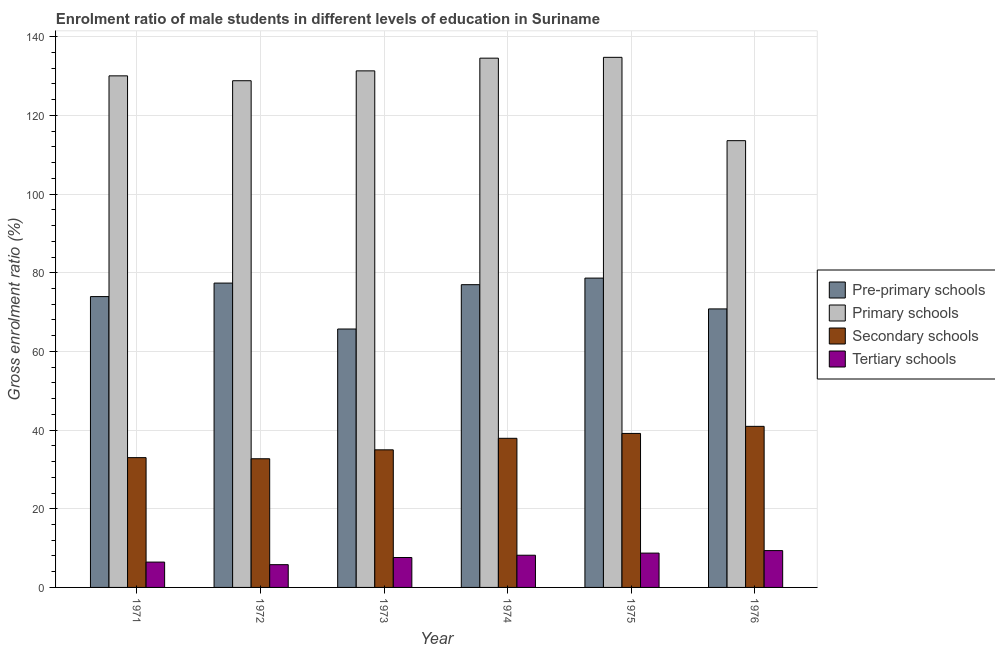How many different coloured bars are there?
Make the answer very short. 4. Are the number of bars per tick equal to the number of legend labels?
Make the answer very short. Yes. Are the number of bars on each tick of the X-axis equal?
Keep it short and to the point. Yes. What is the label of the 4th group of bars from the left?
Keep it short and to the point. 1974. What is the gross enrolment ratio(female) in secondary schools in 1974?
Make the answer very short. 37.91. Across all years, what is the maximum gross enrolment ratio(female) in secondary schools?
Your response must be concise. 40.95. Across all years, what is the minimum gross enrolment ratio(female) in primary schools?
Ensure brevity in your answer.  113.58. In which year was the gross enrolment ratio(female) in tertiary schools maximum?
Make the answer very short. 1976. What is the total gross enrolment ratio(female) in tertiary schools in the graph?
Your response must be concise. 46.11. What is the difference between the gross enrolment ratio(female) in primary schools in 1975 and that in 1976?
Your answer should be very brief. 21.19. What is the difference between the gross enrolment ratio(female) in tertiary schools in 1976 and the gross enrolment ratio(female) in secondary schools in 1975?
Ensure brevity in your answer.  0.64. What is the average gross enrolment ratio(female) in primary schools per year?
Provide a succinct answer. 128.85. In how many years, is the gross enrolment ratio(female) in secondary schools greater than 40 %?
Your answer should be very brief. 1. What is the ratio of the gross enrolment ratio(female) in secondary schools in 1971 to that in 1976?
Offer a very short reply. 0.81. Is the difference between the gross enrolment ratio(female) in pre-primary schools in 1971 and 1974 greater than the difference between the gross enrolment ratio(female) in secondary schools in 1971 and 1974?
Make the answer very short. No. What is the difference between the highest and the second highest gross enrolment ratio(female) in primary schools?
Your answer should be very brief. 0.21. What is the difference between the highest and the lowest gross enrolment ratio(female) in pre-primary schools?
Provide a short and direct response. 12.94. In how many years, is the gross enrolment ratio(female) in pre-primary schools greater than the average gross enrolment ratio(female) in pre-primary schools taken over all years?
Offer a terse response. 4. What does the 1st bar from the left in 1973 represents?
Give a very brief answer. Pre-primary schools. What does the 3rd bar from the right in 1972 represents?
Ensure brevity in your answer.  Primary schools. Is it the case that in every year, the sum of the gross enrolment ratio(female) in pre-primary schools and gross enrolment ratio(female) in primary schools is greater than the gross enrolment ratio(female) in secondary schools?
Your response must be concise. Yes. How many bars are there?
Provide a short and direct response. 24. Are the values on the major ticks of Y-axis written in scientific E-notation?
Keep it short and to the point. No. Does the graph contain any zero values?
Ensure brevity in your answer.  No. How are the legend labels stacked?
Ensure brevity in your answer.  Vertical. What is the title of the graph?
Keep it short and to the point. Enrolment ratio of male students in different levels of education in Suriname. What is the label or title of the Y-axis?
Your answer should be very brief. Gross enrolment ratio (%). What is the Gross enrolment ratio (%) of Pre-primary schools in 1971?
Keep it short and to the point. 73.94. What is the Gross enrolment ratio (%) of Primary schools in 1971?
Your answer should be compact. 130.06. What is the Gross enrolment ratio (%) of Secondary schools in 1971?
Give a very brief answer. 33. What is the Gross enrolment ratio (%) in Tertiary schools in 1971?
Ensure brevity in your answer.  6.44. What is the Gross enrolment ratio (%) of Pre-primary schools in 1972?
Keep it short and to the point. 77.37. What is the Gross enrolment ratio (%) in Primary schools in 1972?
Provide a short and direct response. 128.82. What is the Gross enrolment ratio (%) of Secondary schools in 1972?
Give a very brief answer. 32.71. What is the Gross enrolment ratio (%) of Tertiary schools in 1972?
Make the answer very short. 5.79. What is the Gross enrolment ratio (%) of Pre-primary schools in 1973?
Provide a succinct answer. 65.7. What is the Gross enrolment ratio (%) in Primary schools in 1973?
Provide a succinct answer. 131.33. What is the Gross enrolment ratio (%) in Secondary schools in 1973?
Make the answer very short. 34.98. What is the Gross enrolment ratio (%) of Tertiary schools in 1973?
Keep it short and to the point. 7.6. What is the Gross enrolment ratio (%) in Pre-primary schools in 1974?
Your answer should be compact. 76.97. What is the Gross enrolment ratio (%) of Primary schools in 1974?
Your answer should be compact. 134.56. What is the Gross enrolment ratio (%) in Secondary schools in 1974?
Provide a short and direct response. 37.91. What is the Gross enrolment ratio (%) of Tertiary schools in 1974?
Provide a short and direct response. 8.19. What is the Gross enrolment ratio (%) of Pre-primary schools in 1975?
Your answer should be very brief. 78.64. What is the Gross enrolment ratio (%) of Primary schools in 1975?
Your answer should be compact. 134.77. What is the Gross enrolment ratio (%) of Secondary schools in 1975?
Your answer should be very brief. 39.15. What is the Gross enrolment ratio (%) of Tertiary schools in 1975?
Your answer should be very brief. 8.72. What is the Gross enrolment ratio (%) of Pre-primary schools in 1976?
Ensure brevity in your answer.  70.81. What is the Gross enrolment ratio (%) of Primary schools in 1976?
Your response must be concise. 113.58. What is the Gross enrolment ratio (%) in Secondary schools in 1976?
Provide a succinct answer. 40.95. What is the Gross enrolment ratio (%) of Tertiary schools in 1976?
Your answer should be very brief. 9.37. Across all years, what is the maximum Gross enrolment ratio (%) in Pre-primary schools?
Ensure brevity in your answer.  78.64. Across all years, what is the maximum Gross enrolment ratio (%) of Primary schools?
Offer a very short reply. 134.77. Across all years, what is the maximum Gross enrolment ratio (%) in Secondary schools?
Ensure brevity in your answer.  40.95. Across all years, what is the maximum Gross enrolment ratio (%) in Tertiary schools?
Give a very brief answer. 9.37. Across all years, what is the minimum Gross enrolment ratio (%) of Pre-primary schools?
Offer a terse response. 65.7. Across all years, what is the minimum Gross enrolment ratio (%) in Primary schools?
Give a very brief answer. 113.58. Across all years, what is the minimum Gross enrolment ratio (%) of Secondary schools?
Your response must be concise. 32.71. Across all years, what is the minimum Gross enrolment ratio (%) in Tertiary schools?
Provide a short and direct response. 5.79. What is the total Gross enrolment ratio (%) in Pre-primary schools in the graph?
Your response must be concise. 443.44. What is the total Gross enrolment ratio (%) of Primary schools in the graph?
Your response must be concise. 773.13. What is the total Gross enrolment ratio (%) in Secondary schools in the graph?
Offer a very short reply. 218.71. What is the total Gross enrolment ratio (%) in Tertiary schools in the graph?
Offer a very short reply. 46.11. What is the difference between the Gross enrolment ratio (%) in Pre-primary schools in 1971 and that in 1972?
Provide a succinct answer. -3.43. What is the difference between the Gross enrolment ratio (%) of Primary schools in 1971 and that in 1972?
Give a very brief answer. 1.24. What is the difference between the Gross enrolment ratio (%) of Secondary schools in 1971 and that in 1972?
Offer a very short reply. 0.29. What is the difference between the Gross enrolment ratio (%) of Tertiary schools in 1971 and that in 1972?
Keep it short and to the point. 0.66. What is the difference between the Gross enrolment ratio (%) of Pre-primary schools in 1971 and that in 1973?
Your response must be concise. 8.24. What is the difference between the Gross enrolment ratio (%) of Primary schools in 1971 and that in 1973?
Provide a short and direct response. -1.26. What is the difference between the Gross enrolment ratio (%) of Secondary schools in 1971 and that in 1973?
Offer a terse response. -1.98. What is the difference between the Gross enrolment ratio (%) of Tertiary schools in 1971 and that in 1973?
Your answer should be very brief. -1.16. What is the difference between the Gross enrolment ratio (%) of Pre-primary schools in 1971 and that in 1974?
Your response must be concise. -3.03. What is the difference between the Gross enrolment ratio (%) in Primary schools in 1971 and that in 1974?
Offer a very short reply. -4.5. What is the difference between the Gross enrolment ratio (%) of Secondary schools in 1971 and that in 1974?
Your response must be concise. -4.91. What is the difference between the Gross enrolment ratio (%) of Tertiary schools in 1971 and that in 1974?
Provide a short and direct response. -1.74. What is the difference between the Gross enrolment ratio (%) of Pre-primary schools in 1971 and that in 1975?
Offer a very short reply. -4.7. What is the difference between the Gross enrolment ratio (%) in Primary schools in 1971 and that in 1975?
Your response must be concise. -4.71. What is the difference between the Gross enrolment ratio (%) of Secondary schools in 1971 and that in 1975?
Keep it short and to the point. -6.15. What is the difference between the Gross enrolment ratio (%) in Tertiary schools in 1971 and that in 1975?
Your response must be concise. -2.28. What is the difference between the Gross enrolment ratio (%) of Pre-primary schools in 1971 and that in 1976?
Make the answer very short. 3.13. What is the difference between the Gross enrolment ratio (%) in Primary schools in 1971 and that in 1976?
Make the answer very short. 16.48. What is the difference between the Gross enrolment ratio (%) of Secondary schools in 1971 and that in 1976?
Your response must be concise. -7.95. What is the difference between the Gross enrolment ratio (%) in Tertiary schools in 1971 and that in 1976?
Your answer should be compact. -2.92. What is the difference between the Gross enrolment ratio (%) in Pre-primary schools in 1972 and that in 1973?
Provide a short and direct response. 11.67. What is the difference between the Gross enrolment ratio (%) of Primary schools in 1972 and that in 1973?
Your answer should be compact. -2.5. What is the difference between the Gross enrolment ratio (%) of Secondary schools in 1972 and that in 1973?
Make the answer very short. -2.27. What is the difference between the Gross enrolment ratio (%) of Tertiary schools in 1972 and that in 1973?
Offer a terse response. -1.82. What is the difference between the Gross enrolment ratio (%) in Pre-primary schools in 1972 and that in 1974?
Provide a short and direct response. 0.4. What is the difference between the Gross enrolment ratio (%) in Primary schools in 1972 and that in 1974?
Offer a terse response. -5.73. What is the difference between the Gross enrolment ratio (%) in Secondary schools in 1972 and that in 1974?
Provide a short and direct response. -5.2. What is the difference between the Gross enrolment ratio (%) in Tertiary schools in 1972 and that in 1974?
Ensure brevity in your answer.  -2.4. What is the difference between the Gross enrolment ratio (%) in Pre-primary schools in 1972 and that in 1975?
Make the answer very short. -1.27. What is the difference between the Gross enrolment ratio (%) of Primary schools in 1972 and that in 1975?
Provide a short and direct response. -5.95. What is the difference between the Gross enrolment ratio (%) in Secondary schools in 1972 and that in 1975?
Provide a succinct answer. -6.44. What is the difference between the Gross enrolment ratio (%) of Tertiary schools in 1972 and that in 1975?
Your response must be concise. -2.94. What is the difference between the Gross enrolment ratio (%) in Pre-primary schools in 1972 and that in 1976?
Your answer should be very brief. 6.56. What is the difference between the Gross enrolment ratio (%) of Primary schools in 1972 and that in 1976?
Keep it short and to the point. 15.24. What is the difference between the Gross enrolment ratio (%) of Secondary schools in 1972 and that in 1976?
Offer a terse response. -8.24. What is the difference between the Gross enrolment ratio (%) of Tertiary schools in 1972 and that in 1976?
Keep it short and to the point. -3.58. What is the difference between the Gross enrolment ratio (%) of Pre-primary schools in 1973 and that in 1974?
Your answer should be compact. -11.27. What is the difference between the Gross enrolment ratio (%) of Primary schools in 1973 and that in 1974?
Make the answer very short. -3.23. What is the difference between the Gross enrolment ratio (%) of Secondary schools in 1973 and that in 1974?
Offer a terse response. -2.93. What is the difference between the Gross enrolment ratio (%) of Tertiary schools in 1973 and that in 1974?
Offer a very short reply. -0.58. What is the difference between the Gross enrolment ratio (%) in Pre-primary schools in 1973 and that in 1975?
Your response must be concise. -12.94. What is the difference between the Gross enrolment ratio (%) of Primary schools in 1973 and that in 1975?
Your answer should be very brief. -3.44. What is the difference between the Gross enrolment ratio (%) in Secondary schools in 1973 and that in 1975?
Make the answer very short. -4.17. What is the difference between the Gross enrolment ratio (%) of Tertiary schools in 1973 and that in 1975?
Your answer should be very brief. -1.12. What is the difference between the Gross enrolment ratio (%) in Pre-primary schools in 1973 and that in 1976?
Keep it short and to the point. -5.11. What is the difference between the Gross enrolment ratio (%) in Primary schools in 1973 and that in 1976?
Your answer should be very brief. 17.74. What is the difference between the Gross enrolment ratio (%) of Secondary schools in 1973 and that in 1976?
Your response must be concise. -5.97. What is the difference between the Gross enrolment ratio (%) in Tertiary schools in 1973 and that in 1976?
Keep it short and to the point. -1.76. What is the difference between the Gross enrolment ratio (%) in Pre-primary schools in 1974 and that in 1975?
Give a very brief answer. -1.67. What is the difference between the Gross enrolment ratio (%) in Primary schools in 1974 and that in 1975?
Offer a terse response. -0.21. What is the difference between the Gross enrolment ratio (%) of Secondary schools in 1974 and that in 1975?
Provide a short and direct response. -1.24. What is the difference between the Gross enrolment ratio (%) in Tertiary schools in 1974 and that in 1975?
Give a very brief answer. -0.54. What is the difference between the Gross enrolment ratio (%) in Pre-primary schools in 1974 and that in 1976?
Offer a very short reply. 6.16. What is the difference between the Gross enrolment ratio (%) of Primary schools in 1974 and that in 1976?
Ensure brevity in your answer.  20.97. What is the difference between the Gross enrolment ratio (%) of Secondary schools in 1974 and that in 1976?
Make the answer very short. -3.04. What is the difference between the Gross enrolment ratio (%) of Tertiary schools in 1974 and that in 1976?
Offer a terse response. -1.18. What is the difference between the Gross enrolment ratio (%) of Pre-primary schools in 1975 and that in 1976?
Give a very brief answer. 7.83. What is the difference between the Gross enrolment ratio (%) in Primary schools in 1975 and that in 1976?
Make the answer very short. 21.19. What is the difference between the Gross enrolment ratio (%) of Secondary schools in 1975 and that in 1976?
Keep it short and to the point. -1.8. What is the difference between the Gross enrolment ratio (%) in Tertiary schools in 1975 and that in 1976?
Give a very brief answer. -0.64. What is the difference between the Gross enrolment ratio (%) of Pre-primary schools in 1971 and the Gross enrolment ratio (%) of Primary schools in 1972?
Give a very brief answer. -54.88. What is the difference between the Gross enrolment ratio (%) in Pre-primary schools in 1971 and the Gross enrolment ratio (%) in Secondary schools in 1972?
Your answer should be very brief. 41.23. What is the difference between the Gross enrolment ratio (%) in Pre-primary schools in 1971 and the Gross enrolment ratio (%) in Tertiary schools in 1972?
Keep it short and to the point. 68.15. What is the difference between the Gross enrolment ratio (%) in Primary schools in 1971 and the Gross enrolment ratio (%) in Secondary schools in 1972?
Offer a very short reply. 97.35. What is the difference between the Gross enrolment ratio (%) of Primary schools in 1971 and the Gross enrolment ratio (%) of Tertiary schools in 1972?
Make the answer very short. 124.28. What is the difference between the Gross enrolment ratio (%) in Secondary schools in 1971 and the Gross enrolment ratio (%) in Tertiary schools in 1972?
Keep it short and to the point. 27.21. What is the difference between the Gross enrolment ratio (%) in Pre-primary schools in 1971 and the Gross enrolment ratio (%) in Primary schools in 1973?
Keep it short and to the point. -57.39. What is the difference between the Gross enrolment ratio (%) in Pre-primary schools in 1971 and the Gross enrolment ratio (%) in Secondary schools in 1973?
Your answer should be compact. 38.96. What is the difference between the Gross enrolment ratio (%) of Pre-primary schools in 1971 and the Gross enrolment ratio (%) of Tertiary schools in 1973?
Offer a terse response. 66.34. What is the difference between the Gross enrolment ratio (%) in Primary schools in 1971 and the Gross enrolment ratio (%) in Secondary schools in 1973?
Your answer should be very brief. 95.08. What is the difference between the Gross enrolment ratio (%) of Primary schools in 1971 and the Gross enrolment ratio (%) of Tertiary schools in 1973?
Ensure brevity in your answer.  122.46. What is the difference between the Gross enrolment ratio (%) in Secondary schools in 1971 and the Gross enrolment ratio (%) in Tertiary schools in 1973?
Offer a very short reply. 25.39. What is the difference between the Gross enrolment ratio (%) in Pre-primary schools in 1971 and the Gross enrolment ratio (%) in Primary schools in 1974?
Make the answer very short. -60.62. What is the difference between the Gross enrolment ratio (%) in Pre-primary schools in 1971 and the Gross enrolment ratio (%) in Secondary schools in 1974?
Your response must be concise. 36.03. What is the difference between the Gross enrolment ratio (%) of Pre-primary schools in 1971 and the Gross enrolment ratio (%) of Tertiary schools in 1974?
Your answer should be very brief. 65.75. What is the difference between the Gross enrolment ratio (%) in Primary schools in 1971 and the Gross enrolment ratio (%) in Secondary schools in 1974?
Your response must be concise. 92.15. What is the difference between the Gross enrolment ratio (%) of Primary schools in 1971 and the Gross enrolment ratio (%) of Tertiary schools in 1974?
Your answer should be very brief. 121.88. What is the difference between the Gross enrolment ratio (%) of Secondary schools in 1971 and the Gross enrolment ratio (%) of Tertiary schools in 1974?
Your answer should be compact. 24.81. What is the difference between the Gross enrolment ratio (%) in Pre-primary schools in 1971 and the Gross enrolment ratio (%) in Primary schools in 1975?
Ensure brevity in your answer.  -60.83. What is the difference between the Gross enrolment ratio (%) of Pre-primary schools in 1971 and the Gross enrolment ratio (%) of Secondary schools in 1975?
Provide a short and direct response. 34.79. What is the difference between the Gross enrolment ratio (%) of Pre-primary schools in 1971 and the Gross enrolment ratio (%) of Tertiary schools in 1975?
Ensure brevity in your answer.  65.22. What is the difference between the Gross enrolment ratio (%) in Primary schools in 1971 and the Gross enrolment ratio (%) in Secondary schools in 1975?
Keep it short and to the point. 90.91. What is the difference between the Gross enrolment ratio (%) in Primary schools in 1971 and the Gross enrolment ratio (%) in Tertiary schools in 1975?
Ensure brevity in your answer.  121.34. What is the difference between the Gross enrolment ratio (%) in Secondary schools in 1971 and the Gross enrolment ratio (%) in Tertiary schools in 1975?
Provide a succinct answer. 24.27. What is the difference between the Gross enrolment ratio (%) of Pre-primary schools in 1971 and the Gross enrolment ratio (%) of Primary schools in 1976?
Offer a very short reply. -39.64. What is the difference between the Gross enrolment ratio (%) of Pre-primary schools in 1971 and the Gross enrolment ratio (%) of Secondary schools in 1976?
Offer a very short reply. 32.99. What is the difference between the Gross enrolment ratio (%) in Pre-primary schools in 1971 and the Gross enrolment ratio (%) in Tertiary schools in 1976?
Give a very brief answer. 64.58. What is the difference between the Gross enrolment ratio (%) in Primary schools in 1971 and the Gross enrolment ratio (%) in Secondary schools in 1976?
Give a very brief answer. 89.11. What is the difference between the Gross enrolment ratio (%) of Primary schools in 1971 and the Gross enrolment ratio (%) of Tertiary schools in 1976?
Your response must be concise. 120.7. What is the difference between the Gross enrolment ratio (%) in Secondary schools in 1971 and the Gross enrolment ratio (%) in Tertiary schools in 1976?
Your answer should be compact. 23.63. What is the difference between the Gross enrolment ratio (%) in Pre-primary schools in 1972 and the Gross enrolment ratio (%) in Primary schools in 1973?
Your answer should be very brief. -53.95. What is the difference between the Gross enrolment ratio (%) of Pre-primary schools in 1972 and the Gross enrolment ratio (%) of Secondary schools in 1973?
Make the answer very short. 42.39. What is the difference between the Gross enrolment ratio (%) in Pre-primary schools in 1972 and the Gross enrolment ratio (%) in Tertiary schools in 1973?
Your response must be concise. 69.77. What is the difference between the Gross enrolment ratio (%) of Primary schools in 1972 and the Gross enrolment ratio (%) of Secondary schools in 1973?
Your answer should be compact. 93.84. What is the difference between the Gross enrolment ratio (%) of Primary schools in 1972 and the Gross enrolment ratio (%) of Tertiary schools in 1973?
Make the answer very short. 121.22. What is the difference between the Gross enrolment ratio (%) of Secondary schools in 1972 and the Gross enrolment ratio (%) of Tertiary schools in 1973?
Offer a very short reply. 25.11. What is the difference between the Gross enrolment ratio (%) in Pre-primary schools in 1972 and the Gross enrolment ratio (%) in Primary schools in 1974?
Your response must be concise. -57.18. What is the difference between the Gross enrolment ratio (%) of Pre-primary schools in 1972 and the Gross enrolment ratio (%) of Secondary schools in 1974?
Your answer should be compact. 39.46. What is the difference between the Gross enrolment ratio (%) in Pre-primary schools in 1972 and the Gross enrolment ratio (%) in Tertiary schools in 1974?
Provide a succinct answer. 69.19. What is the difference between the Gross enrolment ratio (%) of Primary schools in 1972 and the Gross enrolment ratio (%) of Secondary schools in 1974?
Keep it short and to the point. 90.91. What is the difference between the Gross enrolment ratio (%) of Primary schools in 1972 and the Gross enrolment ratio (%) of Tertiary schools in 1974?
Your answer should be very brief. 120.64. What is the difference between the Gross enrolment ratio (%) of Secondary schools in 1972 and the Gross enrolment ratio (%) of Tertiary schools in 1974?
Provide a short and direct response. 24.53. What is the difference between the Gross enrolment ratio (%) in Pre-primary schools in 1972 and the Gross enrolment ratio (%) in Primary schools in 1975?
Provide a succinct answer. -57.4. What is the difference between the Gross enrolment ratio (%) of Pre-primary schools in 1972 and the Gross enrolment ratio (%) of Secondary schools in 1975?
Offer a terse response. 38.22. What is the difference between the Gross enrolment ratio (%) in Pre-primary schools in 1972 and the Gross enrolment ratio (%) in Tertiary schools in 1975?
Offer a terse response. 68.65. What is the difference between the Gross enrolment ratio (%) of Primary schools in 1972 and the Gross enrolment ratio (%) of Secondary schools in 1975?
Provide a short and direct response. 89.67. What is the difference between the Gross enrolment ratio (%) in Primary schools in 1972 and the Gross enrolment ratio (%) in Tertiary schools in 1975?
Ensure brevity in your answer.  120.1. What is the difference between the Gross enrolment ratio (%) in Secondary schools in 1972 and the Gross enrolment ratio (%) in Tertiary schools in 1975?
Offer a very short reply. 23.99. What is the difference between the Gross enrolment ratio (%) of Pre-primary schools in 1972 and the Gross enrolment ratio (%) of Primary schools in 1976?
Make the answer very short. -36.21. What is the difference between the Gross enrolment ratio (%) in Pre-primary schools in 1972 and the Gross enrolment ratio (%) in Secondary schools in 1976?
Give a very brief answer. 36.42. What is the difference between the Gross enrolment ratio (%) in Pre-primary schools in 1972 and the Gross enrolment ratio (%) in Tertiary schools in 1976?
Your answer should be very brief. 68.01. What is the difference between the Gross enrolment ratio (%) in Primary schools in 1972 and the Gross enrolment ratio (%) in Secondary schools in 1976?
Your answer should be very brief. 87.87. What is the difference between the Gross enrolment ratio (%) of Primary schools in 1972 and the Gross enrolment ratio (%) of Tertiary schools in 1976?
Provide a succinct answer. 119.46. What is the difference between the Gross enrolment ratio (%) of Secondary schools in 1972 and the Gross enrolment ratio (%) of Tertiary schools in 1976?
Ensure brevity in your answer.  23.35. What is the difference between the Gross enrolment ratio (%) of Pre-primary schools in 1973 and the Gross enrolment ratio (%) of Primary schools in 1974?
Your response must be concise. -68.86. What is the difference between the Gross enrolment ratio (%) of Pre-primary schools in 1973 and the Gross enrolment ratio (%) of Secondary schools in 1974?
Offer a terse response. 27.79. What is the difference between the Gross enrolment ratio (%) in Pre-primary schools in 1973 and the Gross enrolment ratio (%) in Tertiary schools in 1974?
Offer a terse response. 57.51. What is the difference between the Gross enrolment ratio (%) in Primary schools in 1973 and the Gross enrolment ratio (%) in Secondary schools in 1974?
Make the answer very short. 93.42. What is the difference between the Gross enrolment ratio (%) in Primary schools in 1973 and the Gross enrolment ratio (%) in Tertiary schools in 1974?
Make the answer very short. 123.14. What is the difference between the Gross enrolment ratio (%) in Secondary schools in 1973 and the Gross enrolment ratio (%) in Tertiary schools in 1974?
Ensure brevity in your answer.  26.79. What is the difference between the Gross enrolment ratio (%) of Pre-primary schools in 1973 and the Gross enrolment ratio (%) of Primary schools in 1975?
Provide a succinct answer. -69.07. What is the difference between the Gross enrolment ratio (%) in Pre-primary schools in 1973 and the Gross enrolment ratio (%) in Secondary schools in 1975?
Your answer should be very brief. 26.55. What is the difference between the Gross enrolment ratio (%) in Pre-primary schools in 1973 and the Gross enrolment ratio (%) in Tertiary schools in 1975?
Your response must be concise. 56.98. What is the difference between the Gross enrolment ratio (%) in Primary schools in 1973 and the Gross enrolment ratio (%) in Secondary schools in 1975?
Provide a short and direct response. 92.18. What is the difference between the Gross enrolment ratio (%) of Primary schools in 1973 and the Gross enrolment ratio (%) of Tertiary schools in 1975?
Your answer should be very brief. 122.6. What is the difference between the Gross enrolment ratio (%) in Secondary schools in 1973 and the Gross enrolment ratio (%) in Tertiary schools in 1975?
Provide a short and direct response. 26.26. What is the difference between the Gross enrolment ratio (%) of Pre-primary schools in 1973 and the Gross enrolment ratio (%) of Primary schools in 1976?
Your answer should be compact. -47.88. What is the difference between the Gross enrolment ratio (%) in Pre-primary schools in 1973 and the Gross enrolment ratio (%) in Secondary schools in 1976?
Provide a short and direct response. 24.75. What is the difference between the Gross enrolment ratio (%) in Pre-primary schools in 1973 and the Gross enrolment ratio (%) in Tertiary schools in 1976?
Give a very brief answer. 56.34. What is the difference between the Gross enrolment ratio (%) in Primary schools in 1973 and the Gross enrolment ratio (%) in Secondary schools in 1976?
Offer a very short reply. 90.38. What is the difference between the Gross enrolment ratio (%) in Primary schools in 1973 and the Gross enrolment ratio (%) in Tertiary schools in 1976?
Provide a succinct answer. 121.96. What is the difference between the Gross enrolment ratio (%) in Secondary schools in 1973 and the Gross enrolment ratio (%) in Tertiary schools in 1976?
Offer a very short reply. 25.62. What is the difference between the Gross enrolment ratio (%) of Pre-primary schools in 1974 and the Gross enrolment ratio (%) of Primary schools in 1975?
Provide a succinct answer. -57.8. What is the difference between the Gross enrolment ratio (%) in Pre-primary schools in 1974 and the Gross enrolment ratio (%) in Secondary schools in 1975?
Keep it short and to the point. 37.82. What is the difference between the Gross enrolment ratio (%) of Pre-primary schools in 1974 and the Gross enrolment ratio (%) of Tertiary schools in 1975?
Offer a terse response. 68.24. What is the difference between the Gross enrolment ratio (%) of Primary schools in 1974 and the Gross enrolment ratio (%) of Secondary schools in 1975?
Offer a very short reply. 95.41. What is the difference between the Gross enrolment ratio (%) of Primary schools in 1974 and the Gross enrolment ratio (%) of Tertiary schools in 1975?
Offer a terse response. 125.83. What is the difference between the Gross enrolment ratio (%) of Secondary schools in 1974 and the Gross enrolment ratio (%) of Tertiary schools in 1975?
Keep it short and to the point. 29.19. What is the difference between the Gross enrolment ratio (%) in Pre-primary schools in 1974 and the Gross enrolment ratio (%) in Primary schools in 1976?
Your response must be concise. -36.62. What is the difference between the Gross enrolment ratio (%) of Pre-primary schools in 1974 and the Gross enrolment ratio (%) of Secondary schools in 1976?
Your answer should be compact. 36.02. What is the difference between the Gross enrolment ratio (%) of Pre-primary schools in 1974 and the Gross enrolment ratio (%) of Tertiary schools in 1976?
Ensure brevity in your answer.  67.6. What is the difference between the Gross enrolment ratio (%) in Primary schools in 1974 and the Gross enrolment ratio (%) in Secondary schools in 1976?
Provide a succinct answer. 93.61. What is the difference between the Gross enrolment ratio (%) in Primary schools in 1974 and the Gross enrolment ratio (%) in Tertiary schools in 1976?
Provide a succinct answer. 125.19. What is the difference between the Gross enrolment ratio (%) in Secondary schools in 1974 and the Gross enrolment ratio (%) in Tertiary schools in 1976?
Offer a very short reply. 28.54. What is the difference between the Gross enrolment ratio (%) in Pre-primary schools in 1975 and the Gross enrolment ratio (%) in Primary schools in 1976?
Keep it short and to the point. -34.94. What is the difference between the Gross enrolment ratio (%) of Pre-primary schools in 1975 and the Gross enrolment ratio (%) of Secondary schools in 1976?
Provide a short and direct response. 37.69. What is the difference between the Gross enrolment ratio (%) in Pre-primary schools in 1975 and the Gross enrolment ratio (%) in Tertiary schools in 1976?
Keep it short and to the point. 69.28. What is the difference between the Gross enrolment ratio (%) of Primary schools in 1975 and the Gross enrolment ratio (%) of Secondary schools in 1976?
Offer a very short reply. 93.82. What is the difference between the Gross enrolment ratio (%) in Primary schools in 1975 and the Gross enrolment ratio (%) in Tertiary schools in 1976?
Provide a succinct answer. 125.4. What is the difference between the Gross enrolment ratio (%) of Secondary schools in 1975 and the Gross enrolment ratio (%) of Tertiary schools in 1976?
Your answer should be very brief. 29.79. What is the average Gross enrolment ratio (%) in Pre-primary schools per year?
Ensure brevity in your answer.  73.91. What is the average Gross enrolment ratio (%) of Primary schools per year?
Offer a very short reply. 128.85. What is the average Gross enrolment ratio (%) of Secondary schools per year?
Keep it short and to the point. 36.45. What is the average Gross enrolment ratio (%) of Tertiary schools per year?
Make the answer very short. 7.69. In the year 1971, what is the difference between the Gross enrolment ratio (%) in Pre-primary schools and Gross enrolment ratio (%) in Primary schools?
Provide a short and direct response. -56.12. In the year 1971, what is the difference between the Gross enrolment ratio (%) of Pre-primary schools and Gross enrolment ratio (%) of Secondary schools?
Make the answer very short. 40.94. In the year 1971, what is the difference between the Gross enrolment ratio (%) in Pre-primary schools and Gross enrolment ratio (%) in Tertiary schools?
Make the answer very short. 67.5. In the year 1971, what is the difference between the Gross enrolment ratio (%) in Primary schools and Gross enrolment ratio (%) in Secondary schools?
Make the answer very short. 97.06. In the year 1971, what is the difference between the Gross enrolment ratio (%) of Primary schools and Gross enrolment ratio (%) of Tertiary schools?
Your answer should be very brief. 123.62. In the year 1971, what is the difference between the Gross enrolment ratio (%) of Secondary schools and Gross enrolment ratio (%) of Tertiary schools?
Make the answer very short. 26.55. In the year 1972, what is the difference between the Gross enrolment ratio (%) in Pre-primary schools and Gross enrolment ratio (%) in Primary schools?
Keep it short and to the point. -51.45. In the year 1972, what is the difference between the Gross enrolment ratio (%) in Pre-primary schools and Gross enrolment ratio (%) in Secondary schools?
Give a very brief answer. 44.66. In the year 1972, what is the difference between the Gross enrolment ratio (%) of Pre-primary schools and Gross enrolment ratio (%) of Tertiary schools?
Make the answer very short. 71.59. In the year 1972, what is the difference between the Gross enrolment ratio (%) of Primary schools and Gross enrolment ratio (%) of Secondary schools?
Give a very brief answer. 96.11. In the year 1972, what is the difference between the Gross enrolment ratio (%) in Primary schools and Gross enrolment ratio (%) in Tertiary schools?
Provide a succinct answer. 123.04. In the year 1972, what is the difference between the Gross enrolment ratio (%) of Secondary schools and Gross enrolment ratio (%) of Tertiary schools?
Your answer should be compact. 26.93. In the year 1973, what is the difference between the Gross enrolment ratio (%) in Pre-primary schools and Gross enrolment ratio (%) in Primary schools?
Your answer should be very brief. -65.63. In the year 1973, what is the difference between the Gross enrolment ratio (%) in Pre-primary schools and Gross enrolment ratio (%) in Secondary schools?
Offer a very short reply. 30.72. In the year 1973, what is the difference between the Gross enrolment ratio (%) of Pre-primary schools and Gross enrolment ratio (%) of Tertiary schools?
Offer a very short reply. 58.1. In the year 1973, what is the difference between the Gross enrolment ratio (%) in Primary schools and Gross enrolment ratio (%) in Secondary schools?
Provide a succinct answer. 96.34. In the year 1973, what is the difference between the Gross enrolment ratio (%) in Primary schools and Gross enrolment ratio (%) in Tertiary schools?
Your answer should be compact. 123.72. In the year 1973, what is the difference between the Gross enrolment ratio (%) of Secondary schools and Gross enrolment ratio (%) of Tertiary schools?
Provide a short and direct response. 27.38. In the year 1974, what is the difference between the Gross enrolment ratio (%) of Pre-primary schools and Gross enrolment ratio (%) of Primary schools?
Offer a terse response. -57.59. In the year 1974, what is the difference between the Gross enrolment ratio (%) in Pre-primary schools and Gross enrolment ratio (%) in Secondary schools?
Your response must be concise. 39.06. In the year 1974, what is the difference between the Gross enrolment ratio (%) of Pre-primary schools and Gross enrolment ratio (%) of Tertiary schools?
Provide a short and direct response. 68.78. In the year 1974, what is the difference between the Gross enrolment ratio (%) in Primary schools and Gross enrolment ratio (%) in Secondary schools?
Give a very brief answer. 96.65. In the year 1974, what is the difference between the Gross enrolment ratio (%) of Primary schools and Gross enrolment ratio (%) of Tertiary schools?
Make the answer very short. 126.37. In the year 1974, what is the difference between the Gross enrolment ratio (%) of Secondary schools and Gross enrolment ratio (%) of Tertiary schools?
Provide a short and direct response. 29.72. In the year 1975, what is the difference between the Gross enrolment ratio (%) of Pre-primary schools and Gross enrolment ratio (%) of Primary schools?
Keep it short and to the point. -56.13. In the year 1975, what is the difference between the Gross enrolment ratio (%) in Pre-primary schools and Gross enrolment ratio (%) in Secondary schools?
Provide a succinct answer. 39.49. In the year 1975, what is the difference between the Gross enrolment ratio (%) in Pre-primary schools and Gross enrolment ratio (%) in Tertiary schools?
Give a very brief answer. 69.92. In the year 1975, what is the difference between the Gross enrolment ratio (%) of Primary schools and Gross enrolment ratio (%) of Secondary schools?
Provide a short and direct response. 95.62. In the year 1975, what is the difference between the Gross enrolment ratio (%) in Primary schools and Gross enrolment ratio (%) in Tertiary schools?
Offer a terse response. 126.05. In the year 1975, what is the difference between the Gross enrolment ratio (%) of Secondary schools and Gross enrolment ratio (%) of Tertiary schools?
Keep it short and to the point. 30.43. In the year 1976, what is the difference between the Gross enrolment ratio (%) in Pre-primary schools and Gross enrolment ratio (%) in Primary schools?
Give a very brief answer. -42.78. In the year 1976, what is the difference between the Gross enrolment ratio (%) in Pre-primary schools and Gross enrolment ratio (%) in Secondary schools?
Make the answer very short. 29.86. In the year 1976, what is the difference between the Gross enrolment ratio (%) in Pre-primary schools and Gross enrolment ratio (%) in Tertiary schools?
Offer a terse response. 61.44. In the year 1976, what is the difference between the Gross enrolment ratio (%) of Primary schools and Gross enrolment ratio (%) of Secondary schools?
Provide a succinct answer. 72.63. In the year 1976, what is the difference between the Gross enrolment ratio (%) in Primary schools and Gross enrolment ratio (%) in Tertiary schools?
Offer a terse response. 104.22. In the year 1976, what is the difference between the Gross enrolment ratio (%) in Secondary schools and Gross enrolment ratio (%) in Tertiary schools?
Give a very brief answer. 31.59. What is the ratio of the Gross enrolment ratio (%) of Pre-primary schools in 1971 to that in 1972?
Provide a short and direct response. 0.96. What is the ratio of the Gross enrolment ratio (%) in Primary schools in 1971 to that in 1972?
Your answer should be compact. 1.01. What is the ratio of the Gross enrolment ratio (%) of Secondary schools in 1971 to that in 1972?
Your answer should be compact. 1.01. What is the ratio of the Gross enrolment ratio (%) of Tertiary schools in 1971 to that in 1972?
Give a very brief answer. 1.11. What is the ratio of the Gross enrolment ratio (%) in Pre-primary schools in 1971 to that in 1973?
Give a very brief answer. 1.13. What is the ratio of the Gross enrolment ratio (%) of Primary schools in 1971 to that in 1973?
Make the answer very short. 0.99. What is the ratio of the Gross enrolment ratio (%) in Secondary schools in 1971 to that in 1973?
Your answer should be very brief. 0.94. What is the ratio of the Gross enrolment ratio (%) of Tertiary schools in 1971 to that in 1973?
Offer a very short reply. 0.85. What is the ratio of the Gross enrolment ratio (%) of Pre-primary schools in 1971 to that in 1974?
Provide a succinct answer. 0.96. What is the ratio of the Gross enrolment ratio (%) of Primary schools in 1971 to that in 1974?
Your answer should be compact. 0.97. What is the ratio of the Gross enrolment ratio (%) in Secondary schools in 1971 to that in 1974?
Your answer should be very brief. 0.87. What is the ratio of the Gross enrolment ratio (%) of Tertiary schools in 1971 to that in 1974?
Ensure brevity in your answer.  0.79. What is the ratio of the Gross enrolment ratio (%) of Pre-primary schools in 1971 to that in 1975?
Offer a terse response. 0.94. What is the ratio of the Gross enrolment ratio (%) of Primary schools in 1971 to that in 1975?
Your response must be concise. 0.97. What is the ratio of the Gross enrolment ratio (%) in Secondary schools in 1971 to that in 1975?
Give a very brief answer. 0.84. What is the ratio of the Gross enrolment ratio (%) in Tertiary schools in 1971 to that in 1975?
Provide a short and direct response. 0.74. What is the ratio of the Gross enrolment ratio (%) in Pre-primary schools in 1971 to that in 1976?
Your answer should be very brief. 1.04. What is the ratio of the Gross enrolment ratio (%) of Primary schools in 1971 to that in 1976?
Your answer should be compact. 1.15. What is the ratio of the Gross enrolment ratio (%) of Secondary schools in 1971 to that in 1976?
Your answer should be very brief. 0.81. What is the ratio of the Gross enrolment ratio (%) of Tertiary schools in 1971 to that in 1976?
Your answer should be compact. 0.69. What is the ratio of the Gross enrolment ratio (%) of Pre-primary schools in 1972 to that in 1973?
Offer a very short reply. 1.18. What is the ratio of the Gross enrolment ratio (%) in Primary schools in 1972 to that in 1973?
Make the answer very short. 0.98. What is the ratio of the Gross enrolment ratio (%) of Secondary schools in 1972 to that in 1973?
Provide a short and direct response. 0.94. What is the ratio of the Gross enrolment ratio (%) of Tertiary schools in 1972 to that in 1973?
Your answer should be compact. 0.76. What is the ratio of the Gross enrolment ratio (%) in Primary schools in 1972 to that in 1974?
Your answer should be very brief. 0.96. What is the ratio of the Gross enrolment ratio (%) in Secondary schools in 1972 to that in 1974?
Give a very brief answer. 0.86. What is the ratio of the Gross enrolment ratio (%) in Tertiary schools in 1972 to that in 1974?
Your answer should be compact. 0.71. What is the ratio of the Gross enrolment ratio (%) in Pre-primary schools in 1972 to that in 1975?
Your response must be concise. 0.98. What is the ratio of the Gross enrolment ratio (%) in Primary schools in 1972 to that in 1975?
Offer a terse response. 0.96. What is the ratio of the Gross enrolment ratio (%) of Secondary schools in 1972 to that in 1975?
Give a very brief answer. 0.84. What is the ratio of the Gross enrolment ratio (%) in Tertiary schools in 1972 to that in 1975?
Provide a short and direct response. 0.66. What is the ratio of the Gross enrolment ratio (%) of Pre-primary schools in 1972 to that in 1976?
Your answer should be compact. 1.09. What is the ratio of the Gross enrolment ratio (%) of Primary schools in 1972 to that in 1976?
Ensure brevity in your answer.  1.13. What is the ratio of the Gross enrolment ratio (%) in Secondary schools in 1972 to that in 1976?
Offer a very short reply. 0.8. What is the ratio of the Gross enrolment ratio (%) of Tertiary schools in 1972 to that in 1976?
Your answer should be very brief. 0.62. What is the ratio of the Gross enrolment ratio (%) of Pre-primary schools in 1973 to that in 1974?
Offer a very short reply. 0.85. What is the ratio of the Gross enrolment ratio (%) in Primary schools in 1973 to that in 1974?
Make the answer very short. 0.98. What is the ratio of the Gross enrolment ratio (%) of Secondary schools in 1973 to that in 1974?
Your answer should be very brief. 0.92. What is the ratio of the Gross enrolment ratio (%) of Tertiary schools in 1973 to that in 1974?
Ensure brevity in your answer.  0.93. What is the ratio of the Gross enrolment ratio (%) of Pre-primary schools in 1973 to that in 1975?
Provide a succinct answer. 0.84. What is the ratio of the Gross enrolment ratio (%) of Primary schools in 1973 to that in 1975?
Make the answer very short. 0.97. What is the ratio of the Gross enrolment ratio (%) of Secondary schools in 1973 to that in 1975?
Your answer should be compact. 0.89. What is the ratio of the Gross enrolment ratio (%) in Tertiary schools in 1973 to that in 1975?
Your answer should be very brief. 0.87. What is the ratio of the Gross enrolment ratio (%) in Pre-primary schools in 1973 to that in 1976?
Your response must be concise. 0.93. What is the ratio of the Gross enrolment ratio (%) in Primary schools in 1973 to that in 1976?
Your answer should be very brief. 1.16. What is the ratio of the Gross enrolment ratio (%) of Secondary schools in 1973 to that in 1976?
Provide a short and direct response. 0.85. What is the ratio of the Gross enrolment ratio (%) in Tertiary schools in 1973 to that in 1976?
Offer a very short reply. 0.81. What is the ratio of the Gross enrolment ratio (%) of Pre-primary schools in 1974 to that in 1975?
Give a very brief answer. 0.98. What is the ratio of the Gross enrolment ratio (%) of Primary schools in 1974 to that in 1975?
Ensure brevity in your answer.  1. What is the ratio of the Gross enrolment ratio (%) of Secondary schools in 1974 to that in 1975?
Give a very brief answer. 0.97. What is the ratio of the Gross enrolment ratio (%) of Tertiary schools in 1974 to that in 1975?
Offer a terse response. 0.94. What is the ratio of the Gross enrolment ratio (%) in Pre-primary schools in 1974 to that in 1976?
Offer a very short reply. 1.09. What is the ratio of the Gross enrolment ratio (%) in Primary schools in 1974 to that in 1976?
Ensure brevity in your answer.  1.18. What is the ratio of the Gross enrolment ratio (%) of Secondary schools in 1974 to that in 1976?
Give a very brief answer. 0.93. What is the ratio of the Gross enrolment ratio (%) in Tertiary schools in 1974 to that in 1976?
Your response must be concise. 0.87. What is the ratio of the Gross enrolment ratio (%) of Pre-primary schools in 1975 to that in 1976?
Ensure brevity in your answer.  1.11. What is the ratio of the Gross enrolment ratio (%) of Primary schools in 1975 to that in 1976?
Offer a terse response. 1.19. What is the ratio of the Gross enrolment ratio (%) of Secondary schools in 1975 to that in 1976?
Offer a very short reply. 0.96. What is the ratio of the Gross enrolment ratio (%) of Tertiary schools in 1975 to that in 1976?
Your response must be concise. 0.93. What is the difference between the highest and the second highest Gross enrolment ratio (%) in Pre-primary schools?
Keep it short and to the point. 1.27. What is the difference between the highest and the second highest Gross enrolment ratio (%) of Primary schools?
Ensure brevity in your answer.  0.21. What is the difference between the highest and the second highest Gross enrolment ratio (%) of Secondary schools?
Give a very brief answer. 1.8. What is the difference between the highest and the second highest Gross enrolment ratio (%) in Tertiary schools?
Offer a very short reply. 0.64. What is the difference between the highest and the lowest Gross enrolment ratio (%) of Pre-primary schools?
Your answer should be compact. 12.94. What is the difference between the highest and the lowest Gross enrolment ratio (%) of Primary schools?
Ensure brevity in your answer.  21.19. What is the difference between the highest and the lowest Gross enrolment ratio (%) in Secondary schools?
Ensure brevity in your answer.  8.24. What is the difference between the highest and the lowest Gross enrolment ratio (%) in Tertiary schools?
Provide a short and direct response. 3.58. 